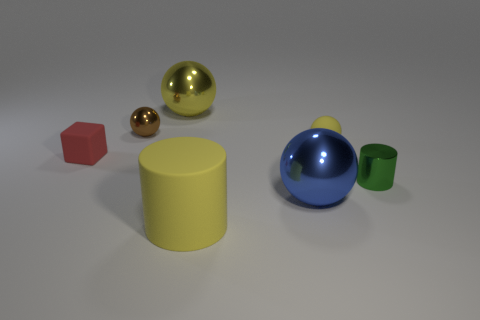There is another sphere that is the same color as the rubber ball; what size is it?
Provide a short and direct response. Large. What number of rubber things are the same shape as the small brown metal thing?
Make the answer very short. 1. What is the shape of the large rubber object that is the same color as the tiny matte sphere?
Make the answer very short. Cylinder. Does the big sphere that is behind the small matte sphere have the same color as the small rubber object on the right side of the tiny red block?
Make the answer very short. Yes. What number of other objects are there of the same material as the small yellow object?
Your response must be concise. 2. The big thing that is behind the large yellow matte thing and in front of the tiny green metallic cylinder has what shape?
Your answer should be compact. Sphere. There is a matte cylinder; does it have the same color as the rubber object that is to the right of the big yellow cylinder?
Keep it short and to the point. Yes. There is a metallic object that is in front of the green thing; is its size the same as the tiny red rubber object?
Offer a terse response. No. There is a big yellow thing that is the same shape as the brown metallic object; what is it made of?
Offer a very short reply. Metal. Does the big blue object have the same shape as the tiny yellow rubber thing?
Give a very brief answer. Yes. 